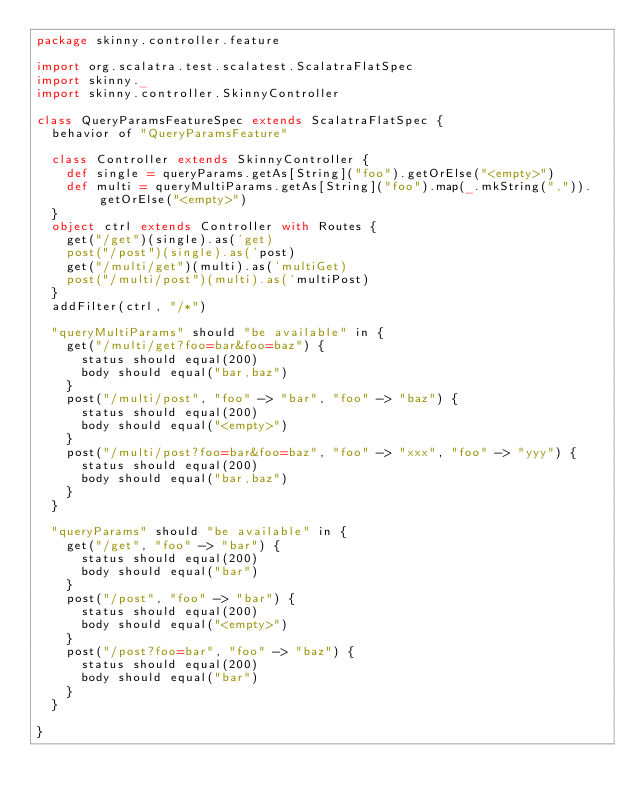Convert code to text. <code><loc_0><loc_0><loc_500><loc_500><_Scala_>package skinny.controller.feature

import org.scalatra.test.scalatest.ScalatraFlatSpec
import skinny._
import skinny.controller.SkinnyController

class QueryParamsFeatureSpec extends ScalatraFlatSpec {
  behavior of "QueryParamsFeature"

  class Controller extends SkinnyController {
    def single = queryParams.getAs[String]("foo").getOrElse("<empty>")
    def multi = queryMultiParams.getAs[String]("foo").map(_.mkString(",")).getOrElse("<empty>")
  }
  object ctrl extends Controller with Routes {
    get("/get")(single).as('get)
    post("/post")(single).as('post)
    get("/multi/get")(multi).as('multiGet)
    post("/multi/post")(multi).as('multiPost)
  }
  addFilter(ctrl, "/*")

  "queryMultiParams" should "be available" in {
    get("/multi/get?foo=bar&foo=baz") {
      status should equal(200)
      body should equal("bar,baz")
    }
    post("/multi/post", "foo" -> "bar", "foo" -> "baz") {
      status should equal(200)
      body should equal("<empty>")
    }
    post("/multi/post?foo=bar&foo=baz", "foo" -> "xxx", "foo" -> "yyy") {
      status should equal(200)
      body should equal("bar,baz")
    }
  }

  "queryParams" should "be available" in {
    get("/get", "foo" -> "bar") {
      status should equal(200)
      body should equal("bar")
    }
    post("/post", "foo" -> "bar") {
      status should equal(200)
      body should equal("<empty>")
    }
    post("/post?foo=bar", "foo" -> "baz") {
      status should equal(200)
      body should equal("bar")
    }
  }

}</code> 